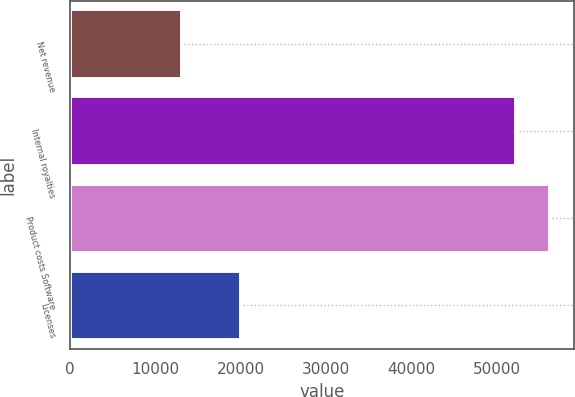Convert chart to OTSL. <chart><loc_0><loc_0><loc_500><loc_500><bar_chart><fcel>Net revenue<fcel>Internal royalties<fcel>Product costs Software<fcel>Licenses<nl><fcel>13144<fcel>52238<fcel>56184.9<fcel>20002<nl></chart> 